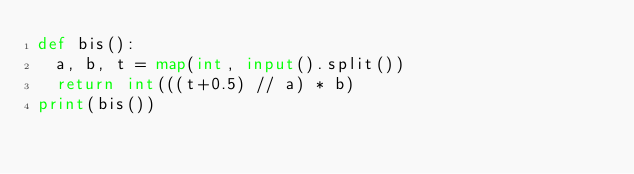<code> <loc_0><loc_0><loc_500><loc_500><_Python_>def bis():
  a, b, t = map(int, input().split())
  return int(((t+0.5) // a) * b)
print(bis())
</code> 